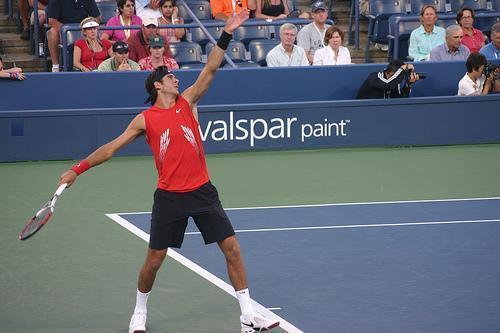How many photographers are sitting in front of the spcetators?
Give a very brief answer. 2. 